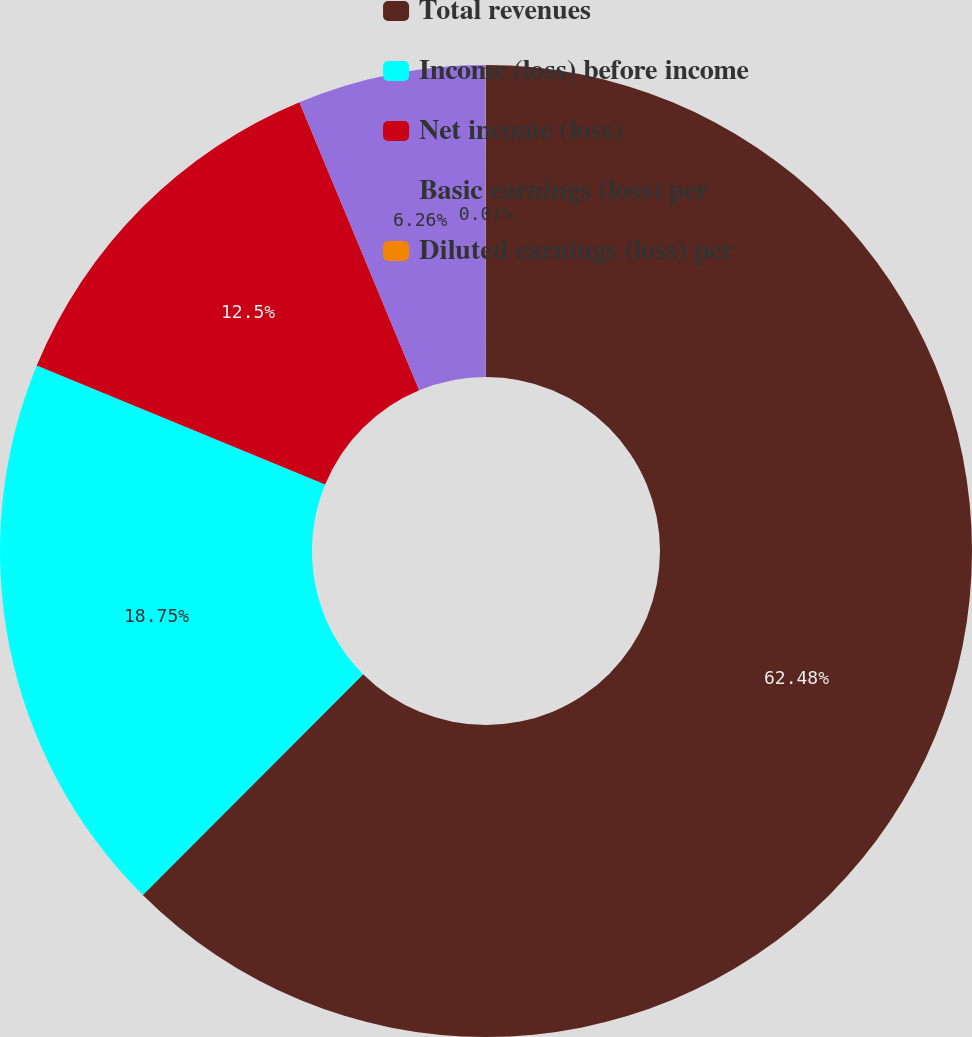<chart> <loc_0><loc_0><loc_500><loc_500><pie_chart><fcel>Total revenues<fcel>Income (loss) before income<fcel>Net income (loss)<fcel>Basic earnings (loss) per<fcel>Diluted earnings (loss) per<nl><fcel>62.48%<fcel>18.75%<fcel>12.5%<fcel>6.26%<fcel>0.01%<nl></chart> 